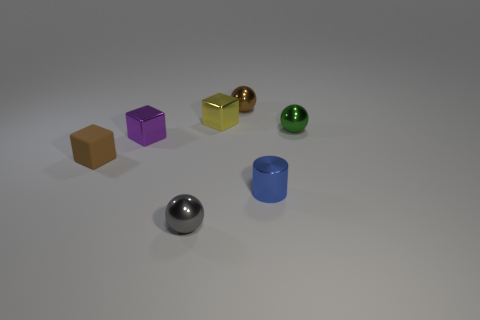Can you tell me the colors of the objects displayed from left to right? From left to right, the objects are colored brown, purple, gold, silver (metallic), green, and blue. 